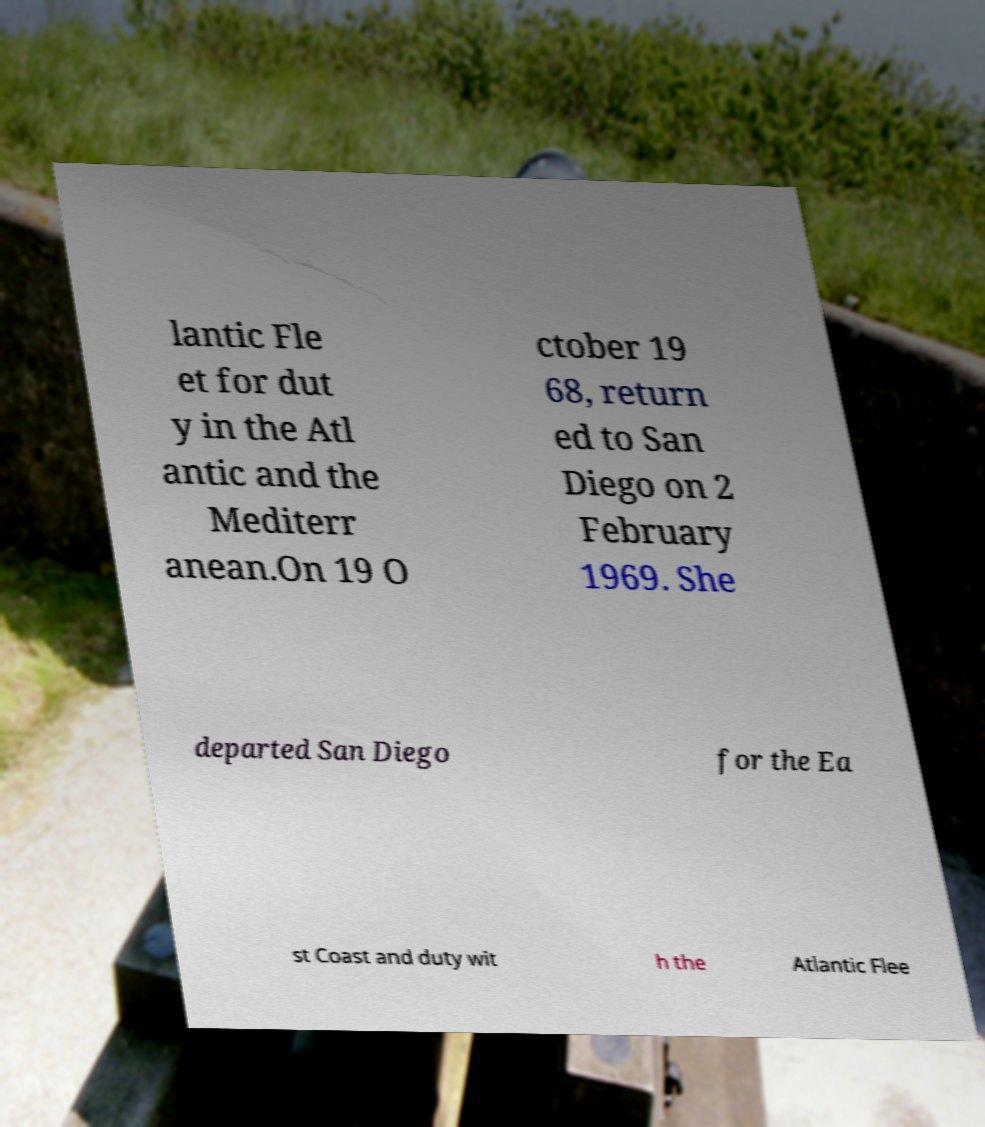Could you extract and type out the text from this image? lantic Fle et for dut y in the Atl antic and the Mediterr anean.On 19 O ctober 19 68, return ed to San Diego on 2 February 1969. She departed San Diego for the Ea st Coast and duty wit h the Atlantic Flee 